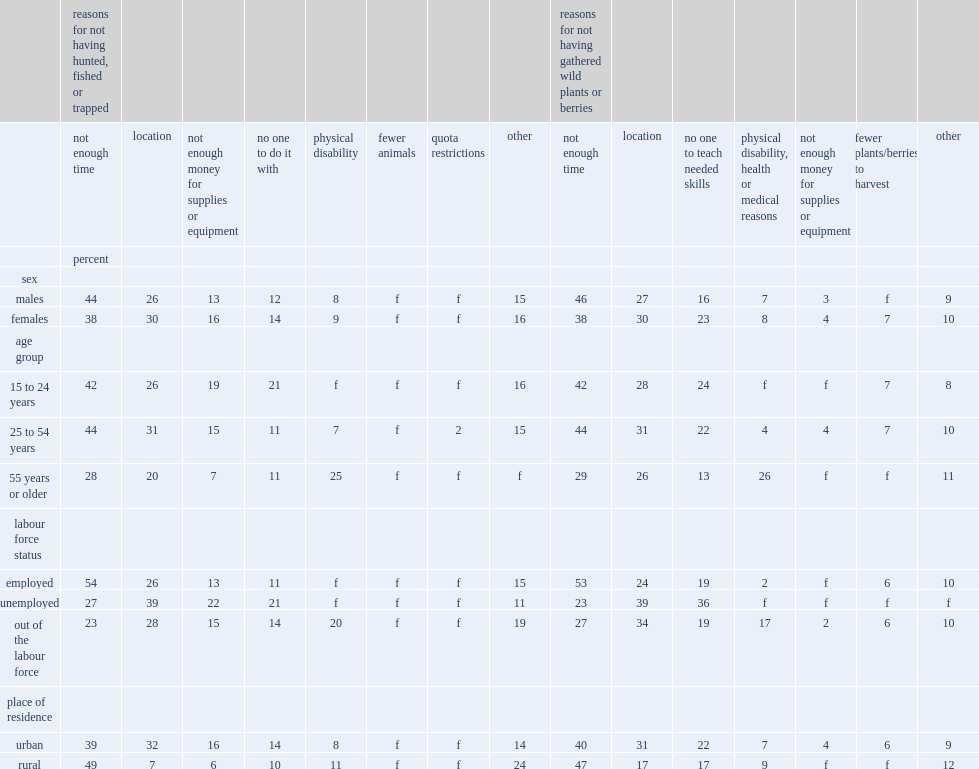Which age group was more likely to cite time barriers for reasons of not having hunted,fished or trapped, youth and young adults or older adults? 15 to 24 years. Which age group was more likely to cite time barriers for reasons of not having hunted,fished or trapped, working-age adults or older adults? 25 to 54 years. Were monetary barriers for not having hunted, fished or trapped less prevalent among older adults or core working-age adults? 55 years or older. Which groups were most likely to indicate they had no one to hunt, fish or trap with than other age groups? 15 to 24 years. Which age group was more likely to identify location as barrier for not having hunted, fished or trapped, working-age adults or older adults? 25 to 54 years. How many percent of indivicuals reported location as a barrier to not having gathered wild plants or berries.? 28.5. Which age group was more likely to cite time as a barrier to not having gathered wild plants or berries, core working-age adults or older adults? 25 to 54 years. Which age group was more likey to identify ot having someone to teach the skills needed as a barrier to not having gathered wild plants or berries, youth and young adults or older adults? 15 to 24 years. Which age group was more likey to identify ot having someone to teach the skills needed as a barrier to not having gathered wild plants or berries, working-age adults or older adults? 25 to 54 years. Which area of off-reserve first nations people cited location as a barrier to hunting, fishing or trapping more frequently, rural areas or urban areas? Urban. Which area of dwellers were more likely to cite monetary reasons for not hunting, fishing or trapping, rural or urban? Urban. Which group of off-reserve first nations people were more likely to face time constraints on hunting, fishing or trapping, employed or unemployed people? Employed. Which group of off-reserve first nations people were more likely to face time constraints on hunting, fishing or trapping, employed or out-of-the-labour-force people? Employed. Which group of people were more likely to cite not having enough money for equipment or supplies as the reason for not hunting, fishing or trapping, employed people or unemployed people? Unemployed. Which group of people were more likely to cite not having enough money for equipment or supplies as the reason for not hunting, fishing or trapping, out of the labour force people or unemployed people? Unemployed. How many times unemployed people were as likely to repoort not having someone to hunt, fish or trap with as a barrier as employed people? 1.909091. Which group of people were more likely to cite location as a barrier to hunt, fish or trap, unemployed or employed people? Unemployed. For gathering wild plants or berries, which group of individuals were more likely to say time constraints prevented them from taking part in these ­activities, the employed individuals or unemployed individuals? Employed. For gathering wild plants or berries, which group of individuals were more likely to say time constraints prevented them from taking part in these ­activities, the employed individuals or out-of-the-labour-force individuals? Employed. 